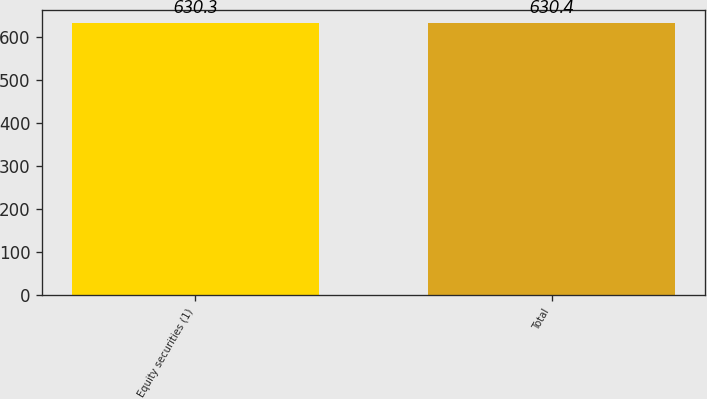<chart> <loc_0><loc_0><loc_500><loc_500><bar_chart><fcel>Equity securities (1)<fcel>Total<nl><fcel>630.3<fcel>630.4<nl></chart> 